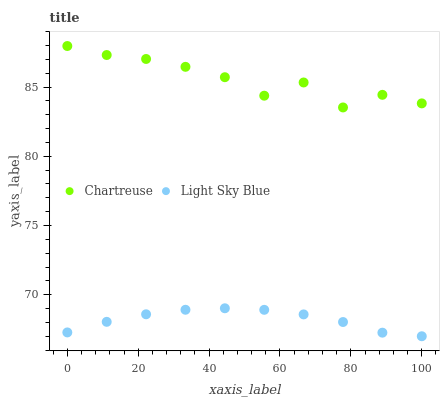Does Light Sky Blue have the minimum area under the curve?
Answer yes or no. Yes. Does Chartreuse have the maximum area under the curve?
Answer yes or no. Yes. Does Light Sky Blue have the maximum area under the curve?
Answer yes or no. No. Is Light Sky Blue the smoothest?
Answer yes or no. Yes. Is Chartreuse the roughest?
Answer yes or no. Yes. Is Light Sky Blue the roughest?
Answer yes or no. No. Does Light Sky Blue have the lowest value?
Answer yes or no. Yes. Does Chartreuse have the highest value?
Answer yes or no. Yes. Does Light Sky Blue have the highest value?
Answer yes or no. No. Is Light Sky Blue less than Chartreuse?
Answer yes or no. Yes. Is Chartreuse greater than Light Sky Blue?
Answer yes or no. Yes. Does Light Sky Blue intersect Chartreuse?
Answer yes or no. No. 